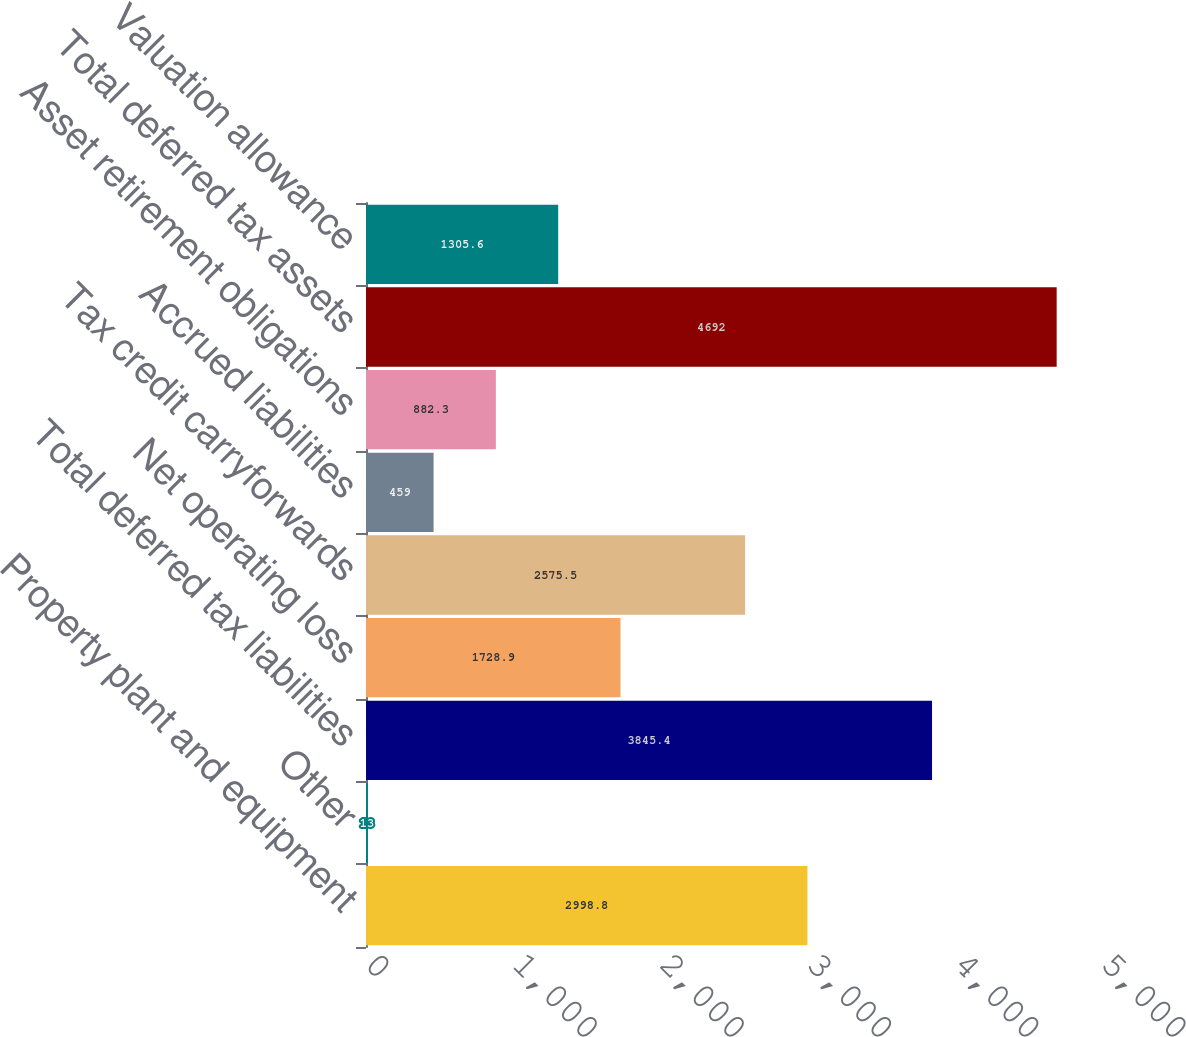<chart> <loc_0><loc_0><loc_500><loc_500><bar_chart><fcel>Property plant and equipment<fcel>Other<fcel>Total deferred tax liabilities<fcel>Net operating loss<fcel>Tax credit carryforwards<fcel>Accrued liabilities<fcel>Asset retirement obligations<fcel>Total deferred tax assets<fcel>Valuation allowance<nl><fcel>2998.8<fcel>13<fcel>3845.4<fcel>1728.9<fcel>2575.5<fcel>459<fcel>882.3<fcel>4692<fcel>1305.6<nl></chart> 